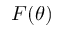<formula> <loc_0><loc_0><loc_500><loc_500>F ( \theta )</formula> 